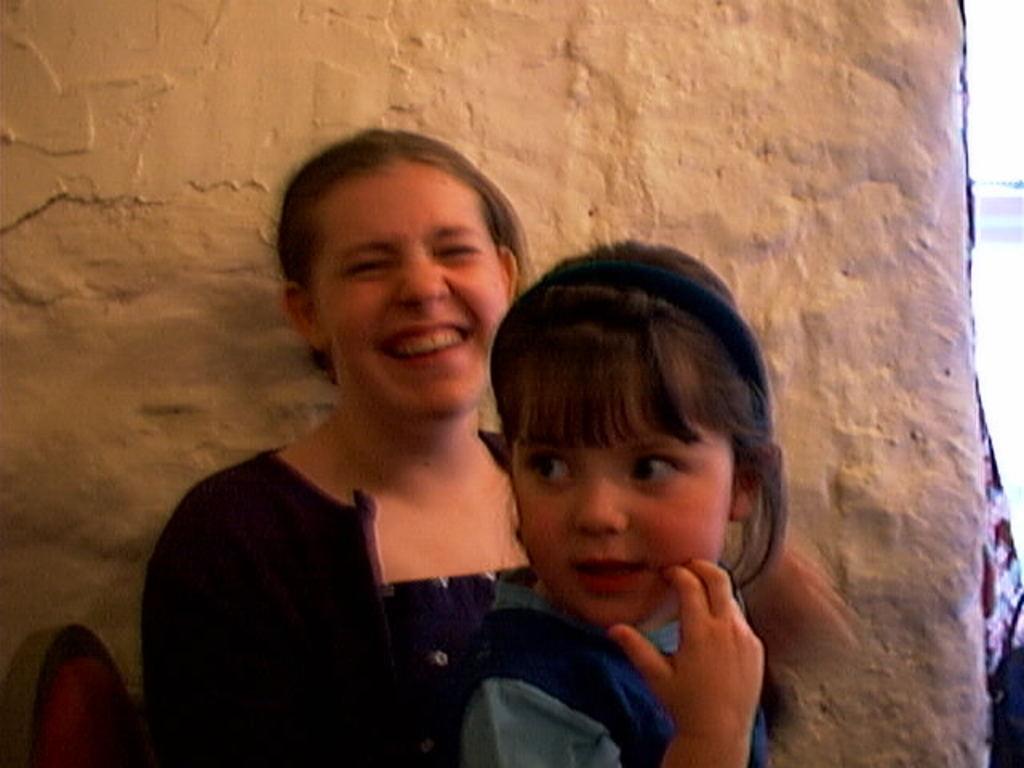Describe this image in one or two sentences. In this image in front there are two persons sitting on the chair. Behind them there is a wall. 